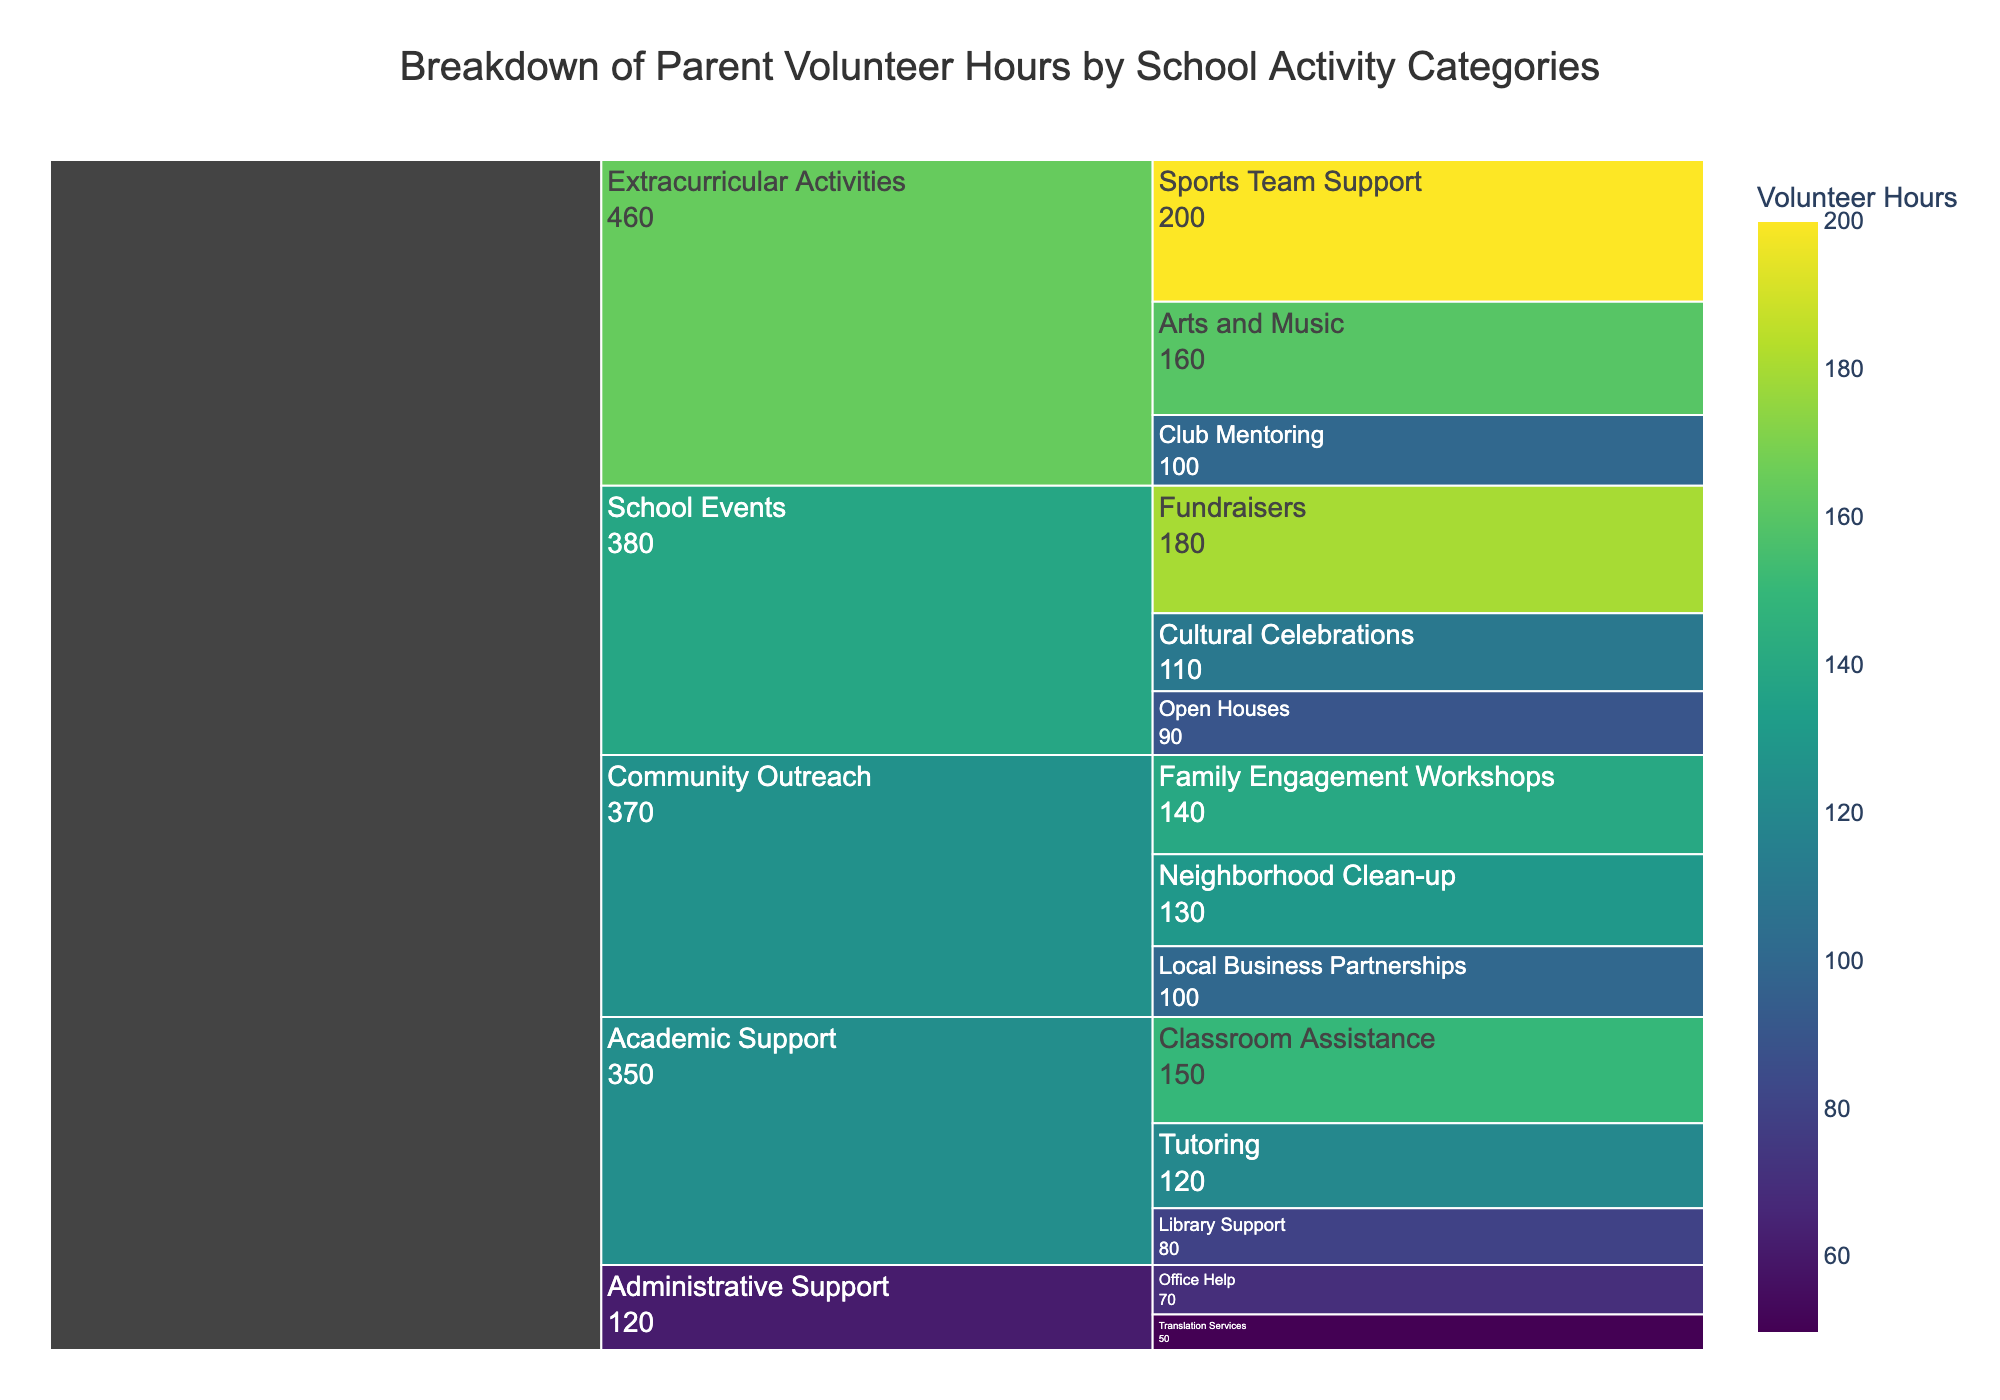What's the title of the chart? The title is typically displayed at the top of the chart. To determine the title, simply look at the text at the top.
Answer: Breakdown of Parent Volunteer Hours by School Activity Categories What category has the highest number of volunteer hours? Look at the highest segment in the icicle chart which has the largest value. The value represents the total volunteer hours for that category.
Answer: Extracurricular Activities How many hours are spent on Fundraisers within School Events? Find the School Events category and then identify the Fundraisers subcategory within it. The number next to the Fundraisers subcategory indicates the hours spent.
Answer: 180 What category has the least number of volunteer hours? Identify the smallest segment within the first level of the icicle chart. The value next to that segment represents the fewest volunteer hours.
Answer: Administrative Support What is the total number of volunteer hours for Academic Support? Sum the hours of all subcategories under Academic Support: Classroom Assistance (150) + Tutoring (120) + Library Support (80). The total is 150 + 120 + 80 = 350.
Answer: 350 How do the hours for Sports Team Support compare to those for Arts and Music? Locate both the Sports Team Support and Arts and Music segments. Compare the values of these two subcategories. Sports Team Support has 200 hours, and Arts and Music has 160 hours, so Sports Team Support has more hours.
Answer: Sports Team Support has more hours What is the average number of hours for subcategories under Community Outreach? Add the hours for all subcategories under Community Outreach: Neighborhood Clean-up (130), Local Business Partnerships (100), and Family Engagement Workshops (140). Total hours are 130 + 100 + 140 = 370. Divide by the number of subcategories (3). The average is 370/3 ≈ 123.33.
Answer: 123.33 Which subcategory within Administrative Support has more volunteer hours? Compare the hours of the subcategories under Administrative Support: Office Help (70) and Translation Services (50). Office Help has more.
Answer: Office Help How many hours are spent on Cultural Celebrations within School Events? Find the School Events category and then identify the Cultural Celebrations subcategory within it. The number next to the Cultural Celebrations subcategory indicates the hours spent.
Answer: 110 What is the sum of volunteer hours for all subcategories under School Events? Sum the hours of all subcategories under School Events: Fundraisers (180), Open Houses (90), and Cultural Celebrations (110). Total hours are 180 + 90 + 110 = 380.
Answer: 380 